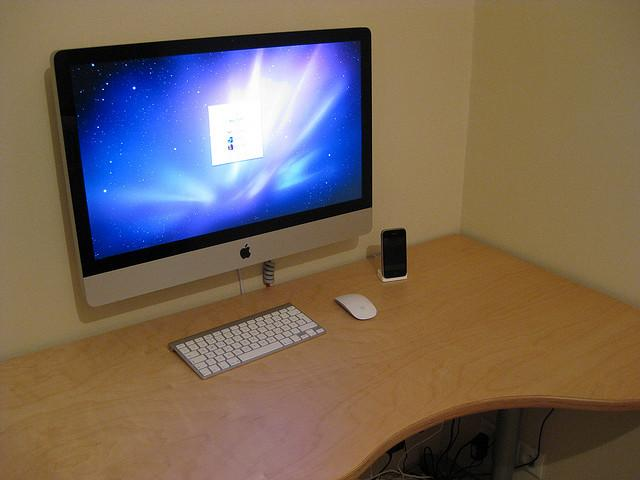What is on the desk? Please explain your reasoning. laptop. A computer keyboard and screen are on a desk. 